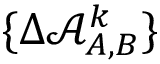<formula> <loc_0><loc_0><loc_500><loc_500>\{ \Delta \mathcal { A } _ { A , B } ^ { k } \}</formula> 